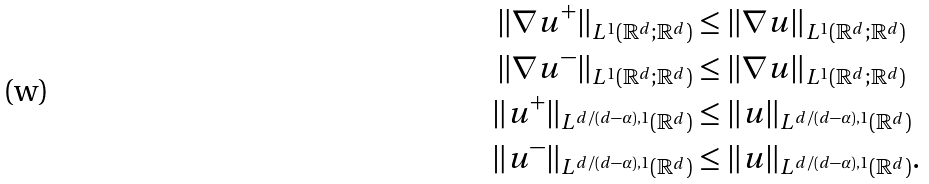Convert formula to latex. <formula><loc_0><loc_0><loc_500><loc_500>\| \nabla u ^ { + } \| _ { L ^ { 1 } ( \mathbb { R } ^ { d } ; \mathbb { R } ^ { d } ) } & \leq \| \nabla u \| _ { L ^ { 1 } ( \mathbb { R } ^ { d } ; \mathbb { R } ^ { d } ) } \\ \| \nabla u ^ { - } \| _ { L ^ { 1 } ( \mathbb { R } ^ { d } ; \mathbb { R } ^ { d } ) } & \leq \| \nabla u \| _ { L ^ { 1 } ( \mathbb { R } ^ { d } ; \mathbb { R } ^ { d } ) } \\ \| u ^ { + } \| _ { L ^ { d / ( d - \alpha ) , 1 } ( \mathbb { R } ^ { d } ) } & \leq \| u \| _ { L ^ { d / ( d - \alpha ) , 1 } ( \mathbb { R } ^ { d } ) } \\ \| u ^ { - } \| _ { L ^ { d / ( d - \alpha ) , 1 } ( \mathbb { R } ^ { d } ) } & \leq \| u \| _ { L ^ { d / ( d - \alpha ) , 1 } ( \mathbb { R } ^ { d } ) } .</formula> 